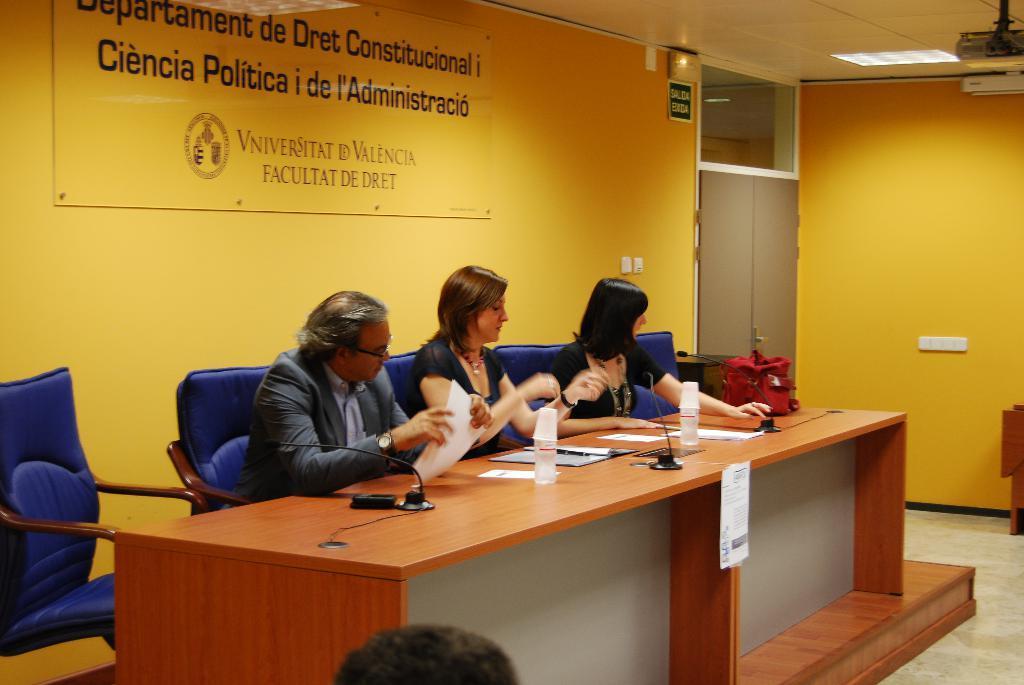In one or two sentences, can you explain what this image depicts? In this image there are 2 woman and a man sitting in the chair ,and in the back ground there is a table , water bottle , glass , paper , microphone , name board , door , light ,projector. 